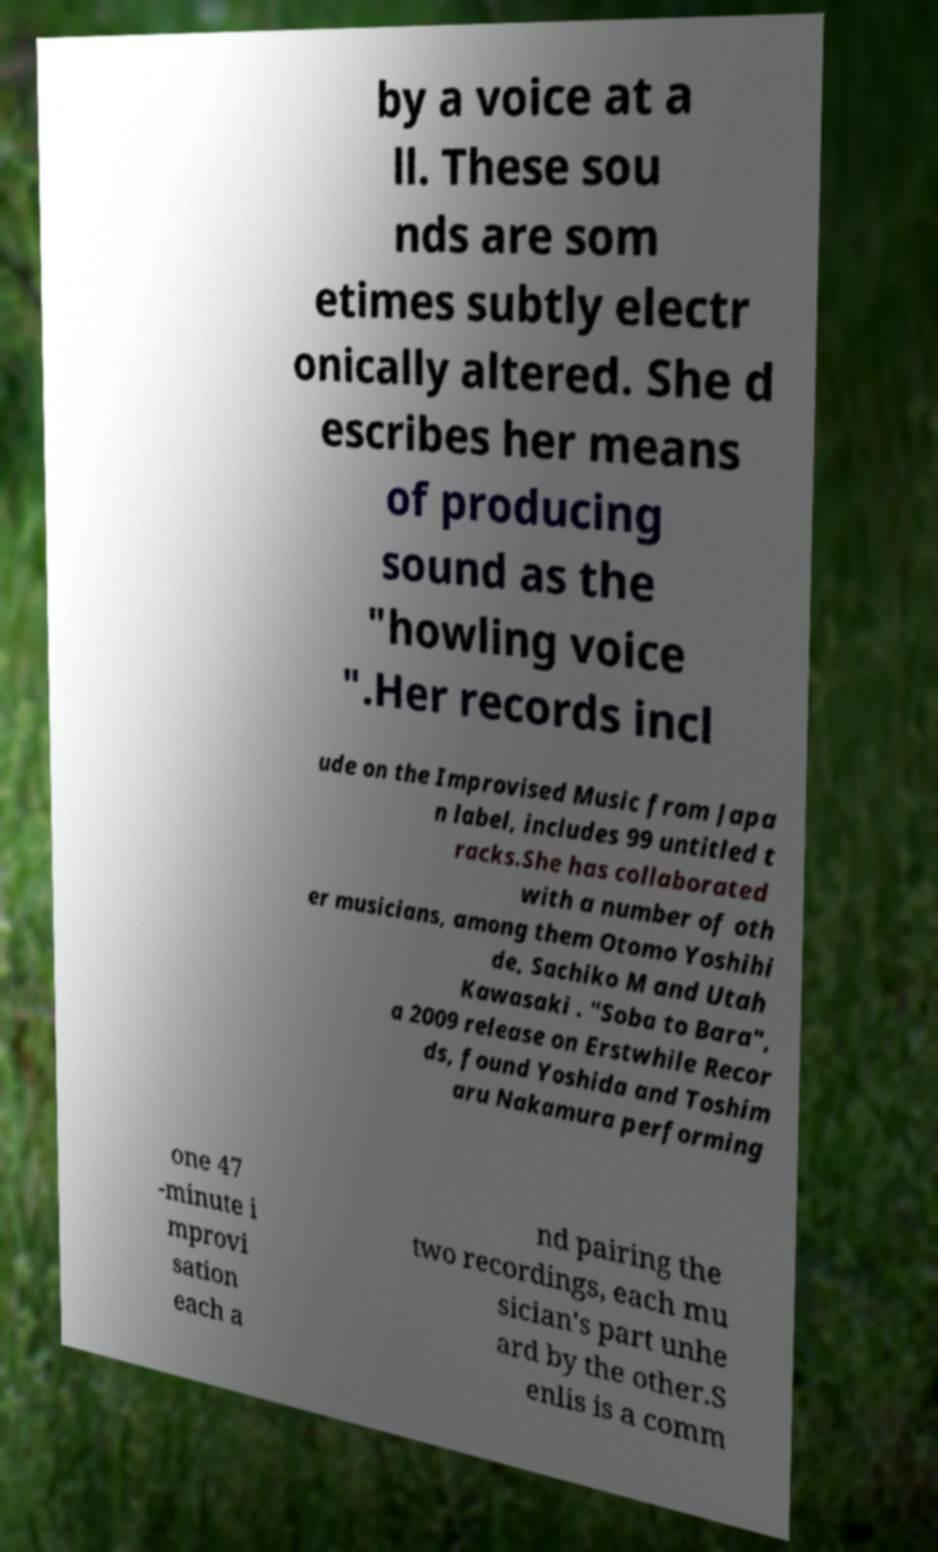Can you accurately transcribe the text from the provided image for me? by a voice at a ll. These sou nds are som etimes subtly electr onically altered. She d escribes her means of producing sound as the "howling voice ".Her records incl ude on the Improvised Music from Japa n label, includes 99 untitled t racks.She has collaborated with a number of oth er musicians, among them Otomo Yoshihi de, Sachiko M and Utah Kawasaki . "Soba to Bara", a 2009 release on Erstwhile Recor ds, found Yoshida and Toshim aru Nakamura performing one 47 -minute i mprovi sation each a nd pairing the two recordings, each mu sician's part unhe ard by the other.S enlis is a comm 